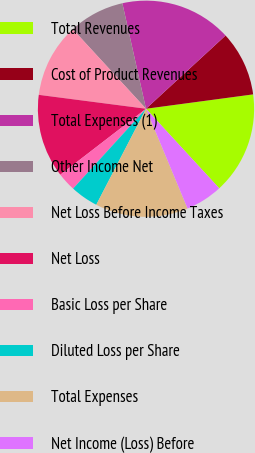Convert chart to OTSL. <chart><loc_0><loc_0><loc_500><loc_500><pie_chart><fcel>Total Revenues<fcel>Cost of Product Revenues<fcel>Total Expenses (1)<fcel>Other Income Net<fcel>Net Loss Before Income Taxes<fcel>Net Loss<fcel>Basic Loss per Share<fcel>Diluted Loss per Share<fcel>Total Expenses<fcel>Net Income (Loss) Before<nl><fcel>15.28%<fcel>9.72%<fcel>16.67%<fcel>8.33%<fcel>11.11%<fcel>12.5%<fcel>2.78%<fcel>4.17%<fcel>13.89%<fcel>5.56%<nl></chart> 